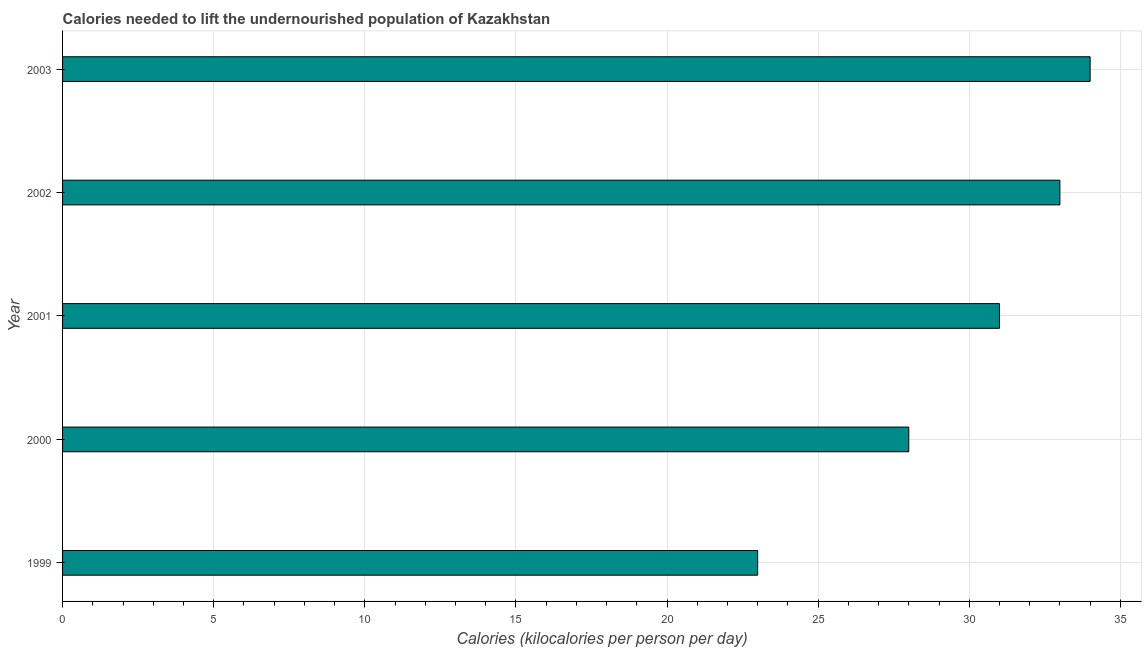What is the title of the graph?
Your response must be concise. Calories needed to lift the undernourished population of Kazakhstan. What is the label or title of the X-axis?
Offer a very short reply. Calories (kilocalories per person per day). What is the label or title of the Y-axis?
Your answer should be very brief. Year. What is the depth of food deficit in 2001?
Give a very brief answer. 31. Across all years, what is the minimum depth of food deficit?
Offer a very short reply. 23. In which year was the depth of food deficit minimum?
Your answer should be compact. 1999. What is the sum of the depth of food deficit?
Make the answer very short. 149. What is the difference between the depth of food deficit in 2002 and 2003?
Give a very brief answer. -1. Do a majority of the years between 1999 and 2003 (inclusive) have depth of food deficit greater than 2 kilocalories?
Offer a very short reply. Yes. What is the ratio of the depth of food deficit in 2000 to that in 2003?
Your answer should be very brief. 0.82. What is the difference between the highest and the second highest depth of food deficit?
Ensure brevity in your answer.  1. Is the sum of the depth of food deficit in 1999 and 2000 greater than the maximum depth of food deficit across all years?
Provide a short and direct response. Yes. What is the difference between the highest and the lowest depth of food deficit?
Your answer should be compact. 11. How many bars are there?
Your response must be concise. 5. Are all the bars in the graph horizontal?
Provide a succinct answer. Yes. How many years are there in the graph?
Provide a short and direct response. 5. What is the Calories (kilocalories per person per day) in 2000?
Your response must be concise. 28. What is the Calories (kilocalories per person per day) in 2002?
Offer a very short reply. 33. What is the Calories (kilocalories per person per day) of 2003?
Provide a succinct answer. 34. What is the difference between the Calories (kilocalories per person per day) in 1999 and 2000?
Provide a succinct answer. -5. What is the difference between the Calories (kilocalories per person per day) in 1999 and 2001?
Your answer should be compact. -8. What is the difference between the Calories (kilocalories per person per day) in 1999 and 2002?
Your answer should be compact. -10. What is the difference between the Calories (kilocalories per person per day) in 1999 and 2003?
Your answer should be very brief. -11. What is the ratio of the Calories (kilocalories per person per day) in 1999 to that in 2000?
Give a very brief answer. 0.82. What is the ratio of the Calories (kilocalories per person per day) in 1999 to that in 2001?
Your answer should be compact. 0.74. What is the ratio of the Calories (kilocalories per person per day) in 1999 to that in 2002?
Your answer should be compact. 0.7. What is the ratio of the Calories (kilocalories per person per day) in 1999 to that in 2003?
Provide a succinct answer. 0.68. What is the ratio of the Calories (kilocalories per person per day) in 2000 to that in 2001?
Make the answer very short. 0.9. What is the ratio of the Calories (kilocalories per person per day) in 2000 to that in 2002?
Provide a succinct answer. 0.85. What is the ratio of the Calories (kilocalories per person per day) in 2000 to that in 2003?
Provide a short and direct response. 0.82. What is the ratio of the Calories (kilocalories per person per day) in 2001 to that in 2002?
Provide a short and direct response. 0.94. What is the ratio of the Calories (kilocalories per person per day) in 2001 to that in 2003?
Keep it short and to the point. 0.91. 